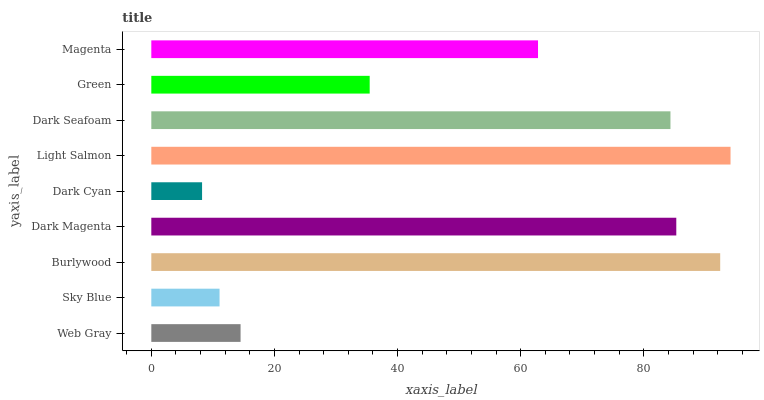Is Dark Cyan the minimum?
Answer yes or no. Yes. Is Light Salmon the maximum?
Answer yes or no. Yes. Is Sky Blue the minimum?
Answer yes or no. No. Is Sky Blue the maximum?
Answer yes or no. No. Is Web Gray greater than Sky Blue?
Answer yes or no. Yes. Is Sky Blue less than Web Gray?
Answer yes or no. Yes. Is Sky Blue greater than Web Gray?
Answer yes or no. No. Is Web Gray less than Sky Blue?
Answer yes or no. No. Is Magenta the high median?
Answer yes or no. Yes. Is Magenta the low median?
Answer yes or no. Yes. Is Web Gray the high median?
Answer yes or no. No. Is Web Gray the low median?
Answer yes or no. No. 